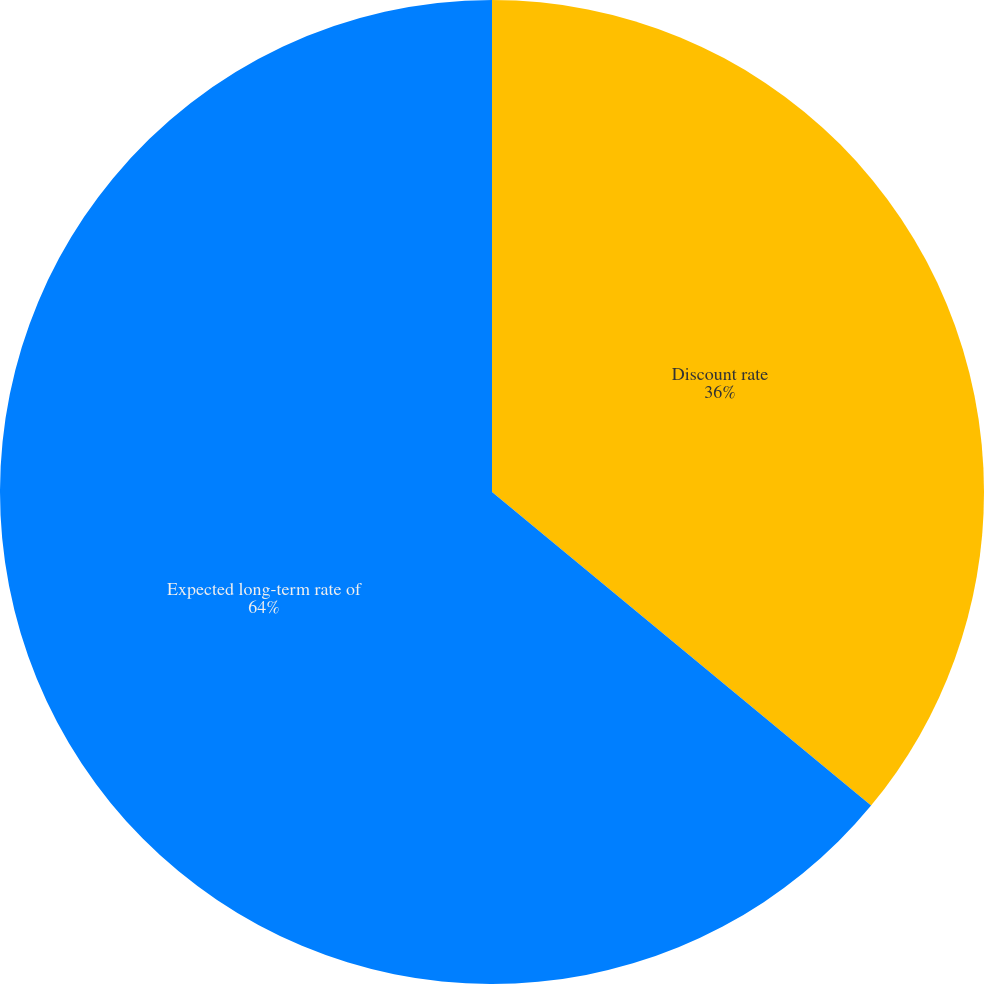Convert chart. <chart><loc_0><loc_0><loc_500><loc_500><pie_chart><fcel>Discount rate<fcel>Expected long-term rate of<nl><fcel>36.0%<fcel>64.0%<nl></chart> 